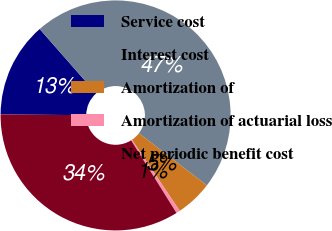Convert chart. <chart><loc_0><loc_0><loc_500><loc_500><pie_chart><fcel>Service cost<fcel>Interest cost<fcel>Amortization of<fcel>Amortization of actuarial loss<fcel>Net periodic benefit cost<nl><fcel>13.39%<fcel>46.88%<fcel>5.17%<fcel>0.54%<fcel>34.02%<nl></chart> 